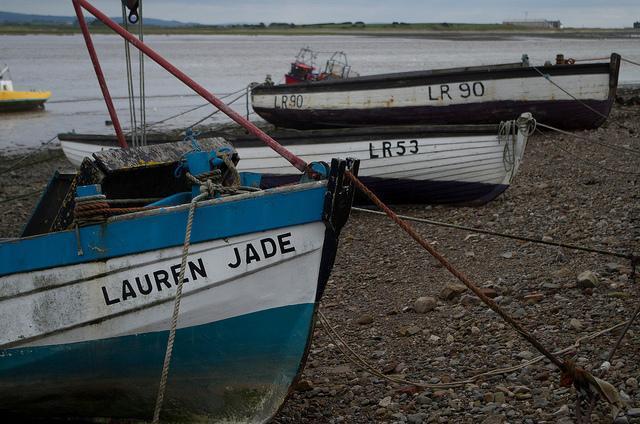What celebrity first name appears on the boat?
Make your selection from the four choices given to correctly answer the question.
Options: Idris elba, jim duggan, tony atlas, lauren cohan. Lauren cohan. 